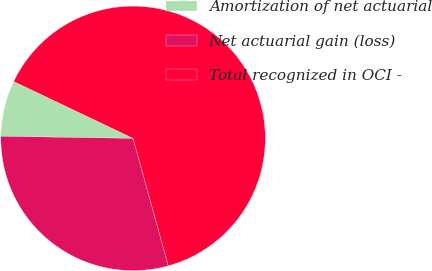<chart> <loc_0><loc_0><loc_500><loc_500><pie_chart><fcel>Amortization of net actuarial<fcel>Net actuarial gain (loss)<fcel>Total recognized in OCI -<nl><fcel>6.82%<fcel>29.55%<fcel>63.64%<nl></chart> 